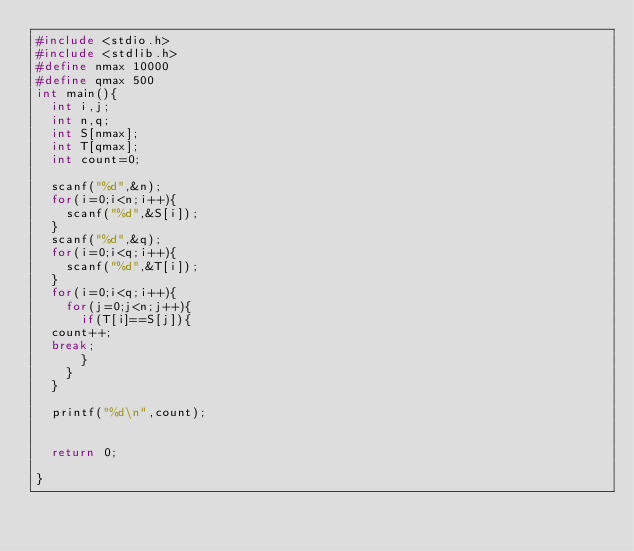<code> <loc_0><loc_0><loc_500><loc_500><_C_>#include <stdio.h>
#include <stdlib.h>
#define nmax 10000
#define qmax 500
int main(){
  int i,j;
  int n,q;
  int S[nmax];
  int T[qmax];
  int count=0;

  scanf("%d",&n);
  for(i=0;i<n;i++){
    scanf("%d",&S[i]);
  }
  scanf("%d",&q);
  for(i=0;i<q;i++){
    scanf("%d",&T[i]);
  }
  for(i=0;i<q;i++){
    for(j=0;j<n;j++){
      if(T[i]==S[j]){
	count++;
	break;
      }
    }
  }

  printf("%d\n",count);
  
  
  return 0;
  
}

</code> 